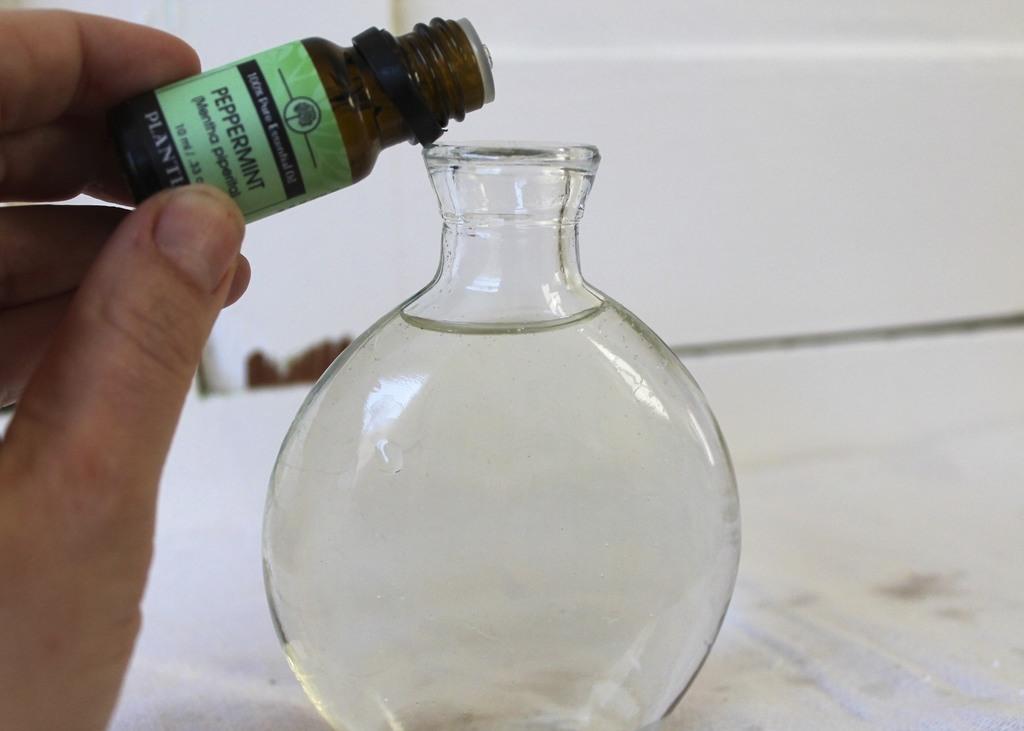Can you describe this image briefly? In this picture we can see a person's hand and there is a chemical bottle in his hand. This is round bottom flask with water in it. 